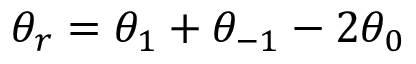Convert formula to latex. <formula><loc_0><loc_0><loc_500><loc_500>\theta _ { r } = \theta _ { 1 } + \theta _ { - 1 } - 2 \theta _ { 0 }</formula> 